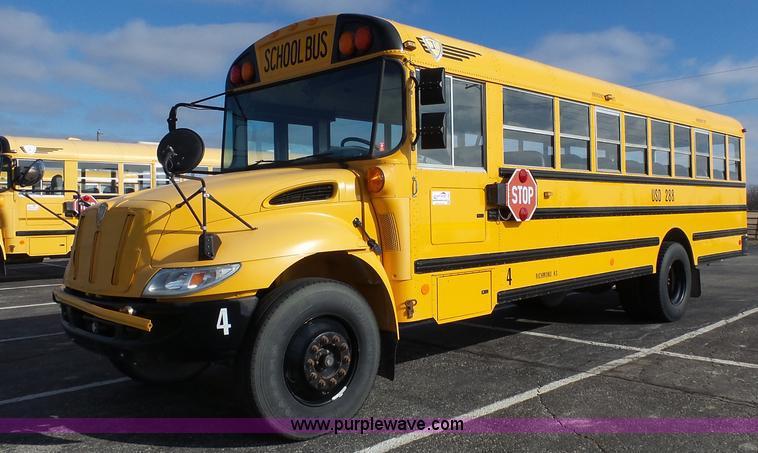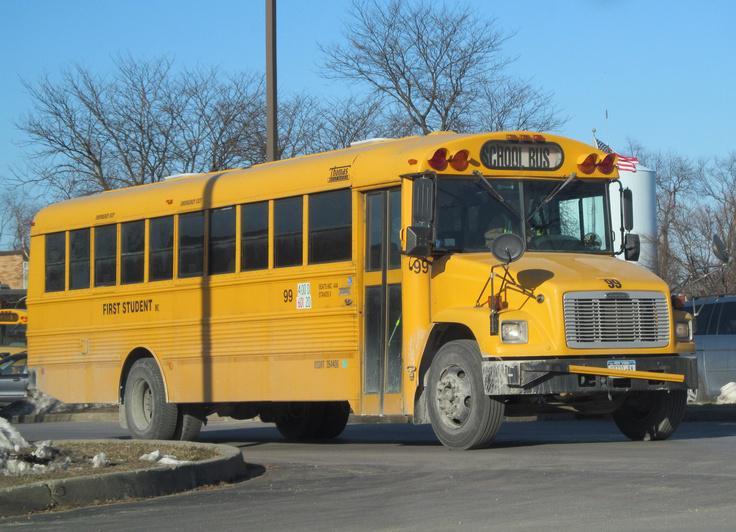The first image is the image on the left, the second image is the image on the right. For the images displayed, is the sentence "One image shows a bus with a flat front, and the other image shows a bus with a non-flat front." factually correct? Answer yes or no. No. The first image is the image on the left, the second image is the image on the right. Examine the images to the left and right. Is the description "Exactly one bus stop sign is visible." accurate? Answer yes or no. Yes. 